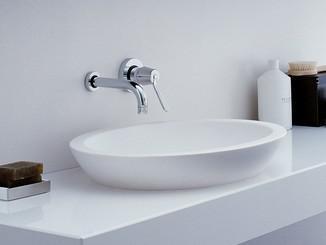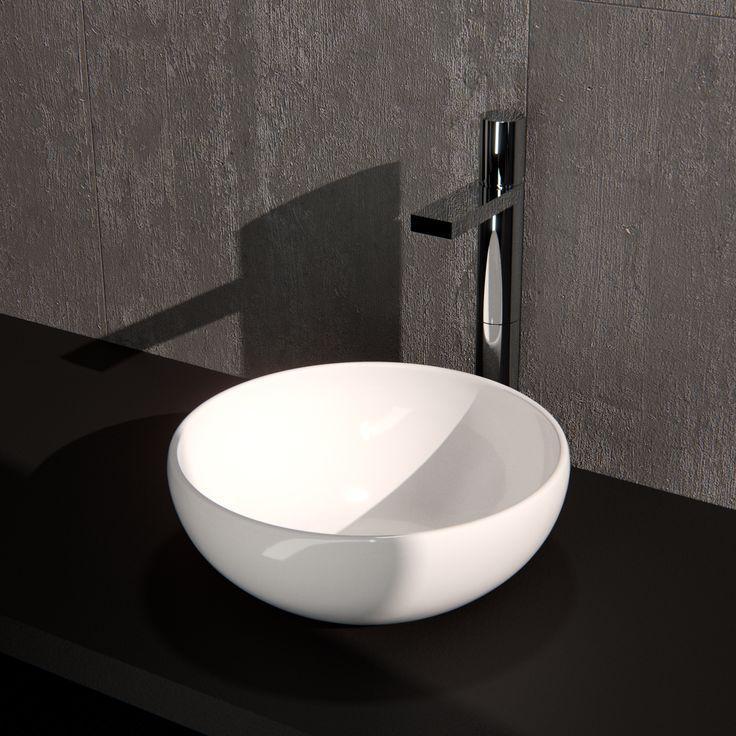The first image is the image on the left, the second image is the image on the right. Considering the images on both sides, is "One white sink is round and one is oval, neither directly attached to a chrome spout fixture that overhangs it." valid? Answer yes or no. Yes. The first image is the image on the left, the second image is the image on the right. Given the left and right images, does the statement "Each sink is rounded, white, sits atop a counter, and has the spout and faucet mounted on the wall above it." hold true? Answer yes or no. Yes. 